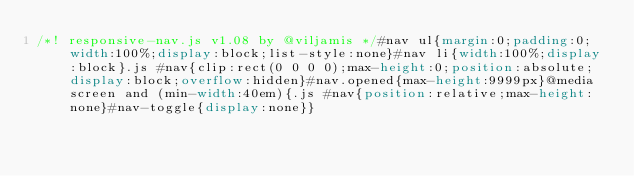<code> <loc_0><loc_0><loc_500><loc_500><_CSS_>/*! responsive-nav.js v1.08 by @viljamis */#nav ul{margin:0;padding:0;width:100%;display:block;list-style:none}#nav li{width:100%;display:block}.js #nav{clip:rect(0 0 0 0);max-height:0;position:absolute;display:block;overflow:hidden}#nav.opened{max-height:9999px}@media screen and (min-width:40em){.js #nav{position:relative;max-height:none}#nav-toggle{display:none}}</code> 